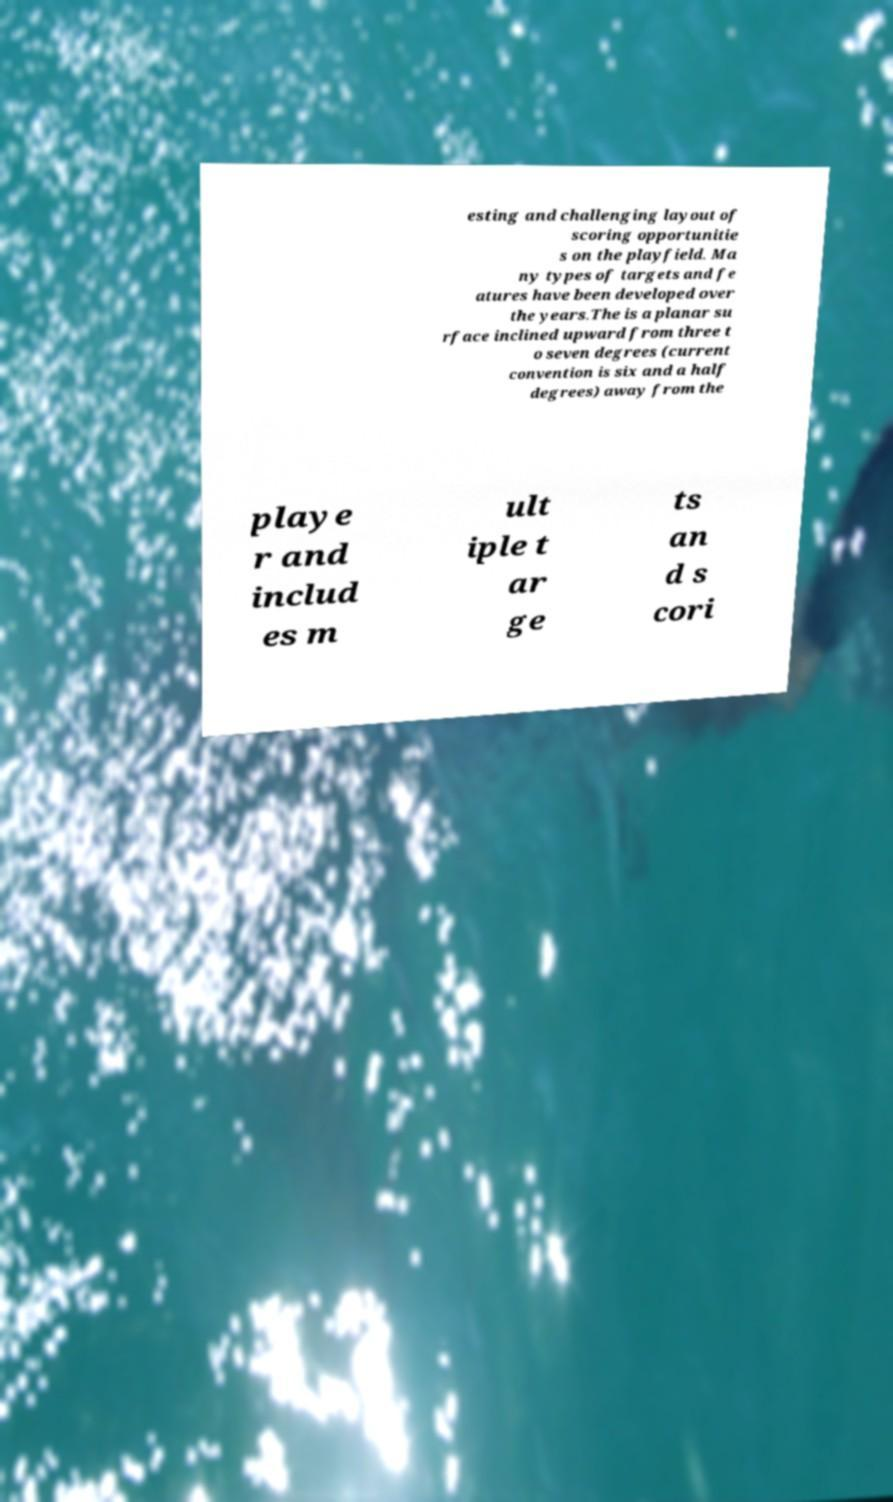For documentation purposes, I need the text within this image transcribed. Could you provide that? esting and challenging layout of scoring opportunitie s on the playfield. Ma ny types of targets and fe atures have been developed over the years.The is a planar su rface inclined upward from three t o seven degrees (current convention is six and a half degrees) away from the playe r and includ es m ult iple t ar ge ts an d s cori 